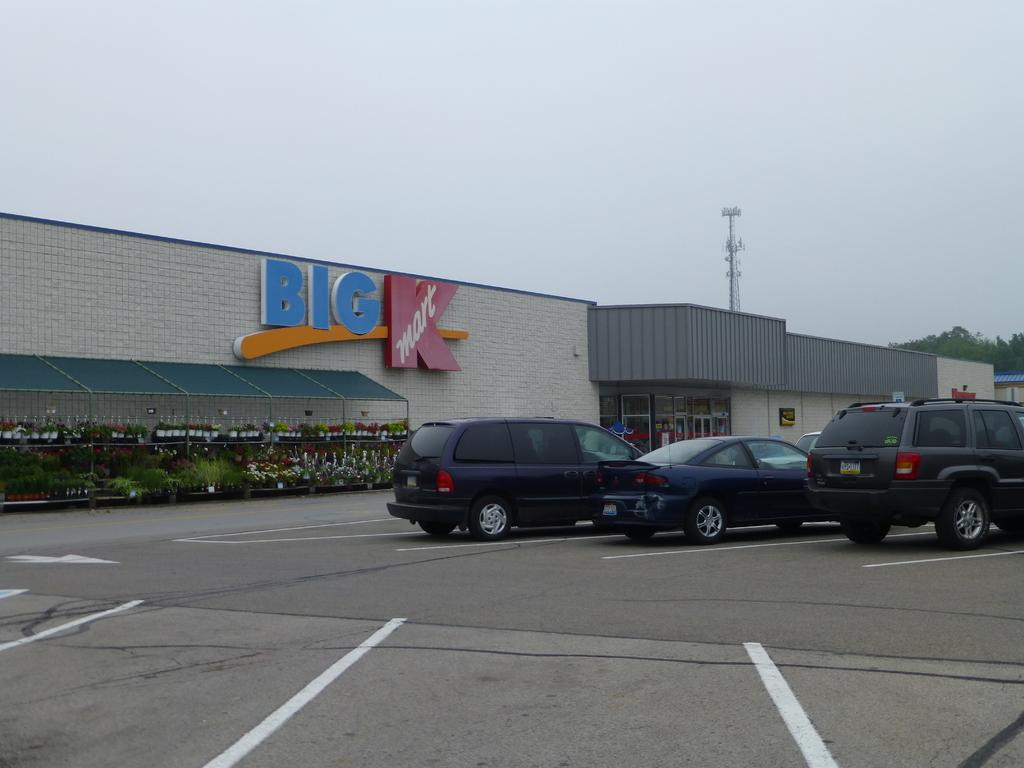What can be seen on the road in the image? Cars are parked on the road in the image. What type of vegetation is present in the image? There are plants with flowers in the image. What structures can be seen in the background of the image? There are buildings, a tower, and trees in the background of the image. What is visible in the sky in the image? The sky is visible in the background of the image. Can you tell me how many basketballs are visible in the image? There are no basketballs present in the image. What type of representative is standing near the tower in the image? There is no representative present in the image. 